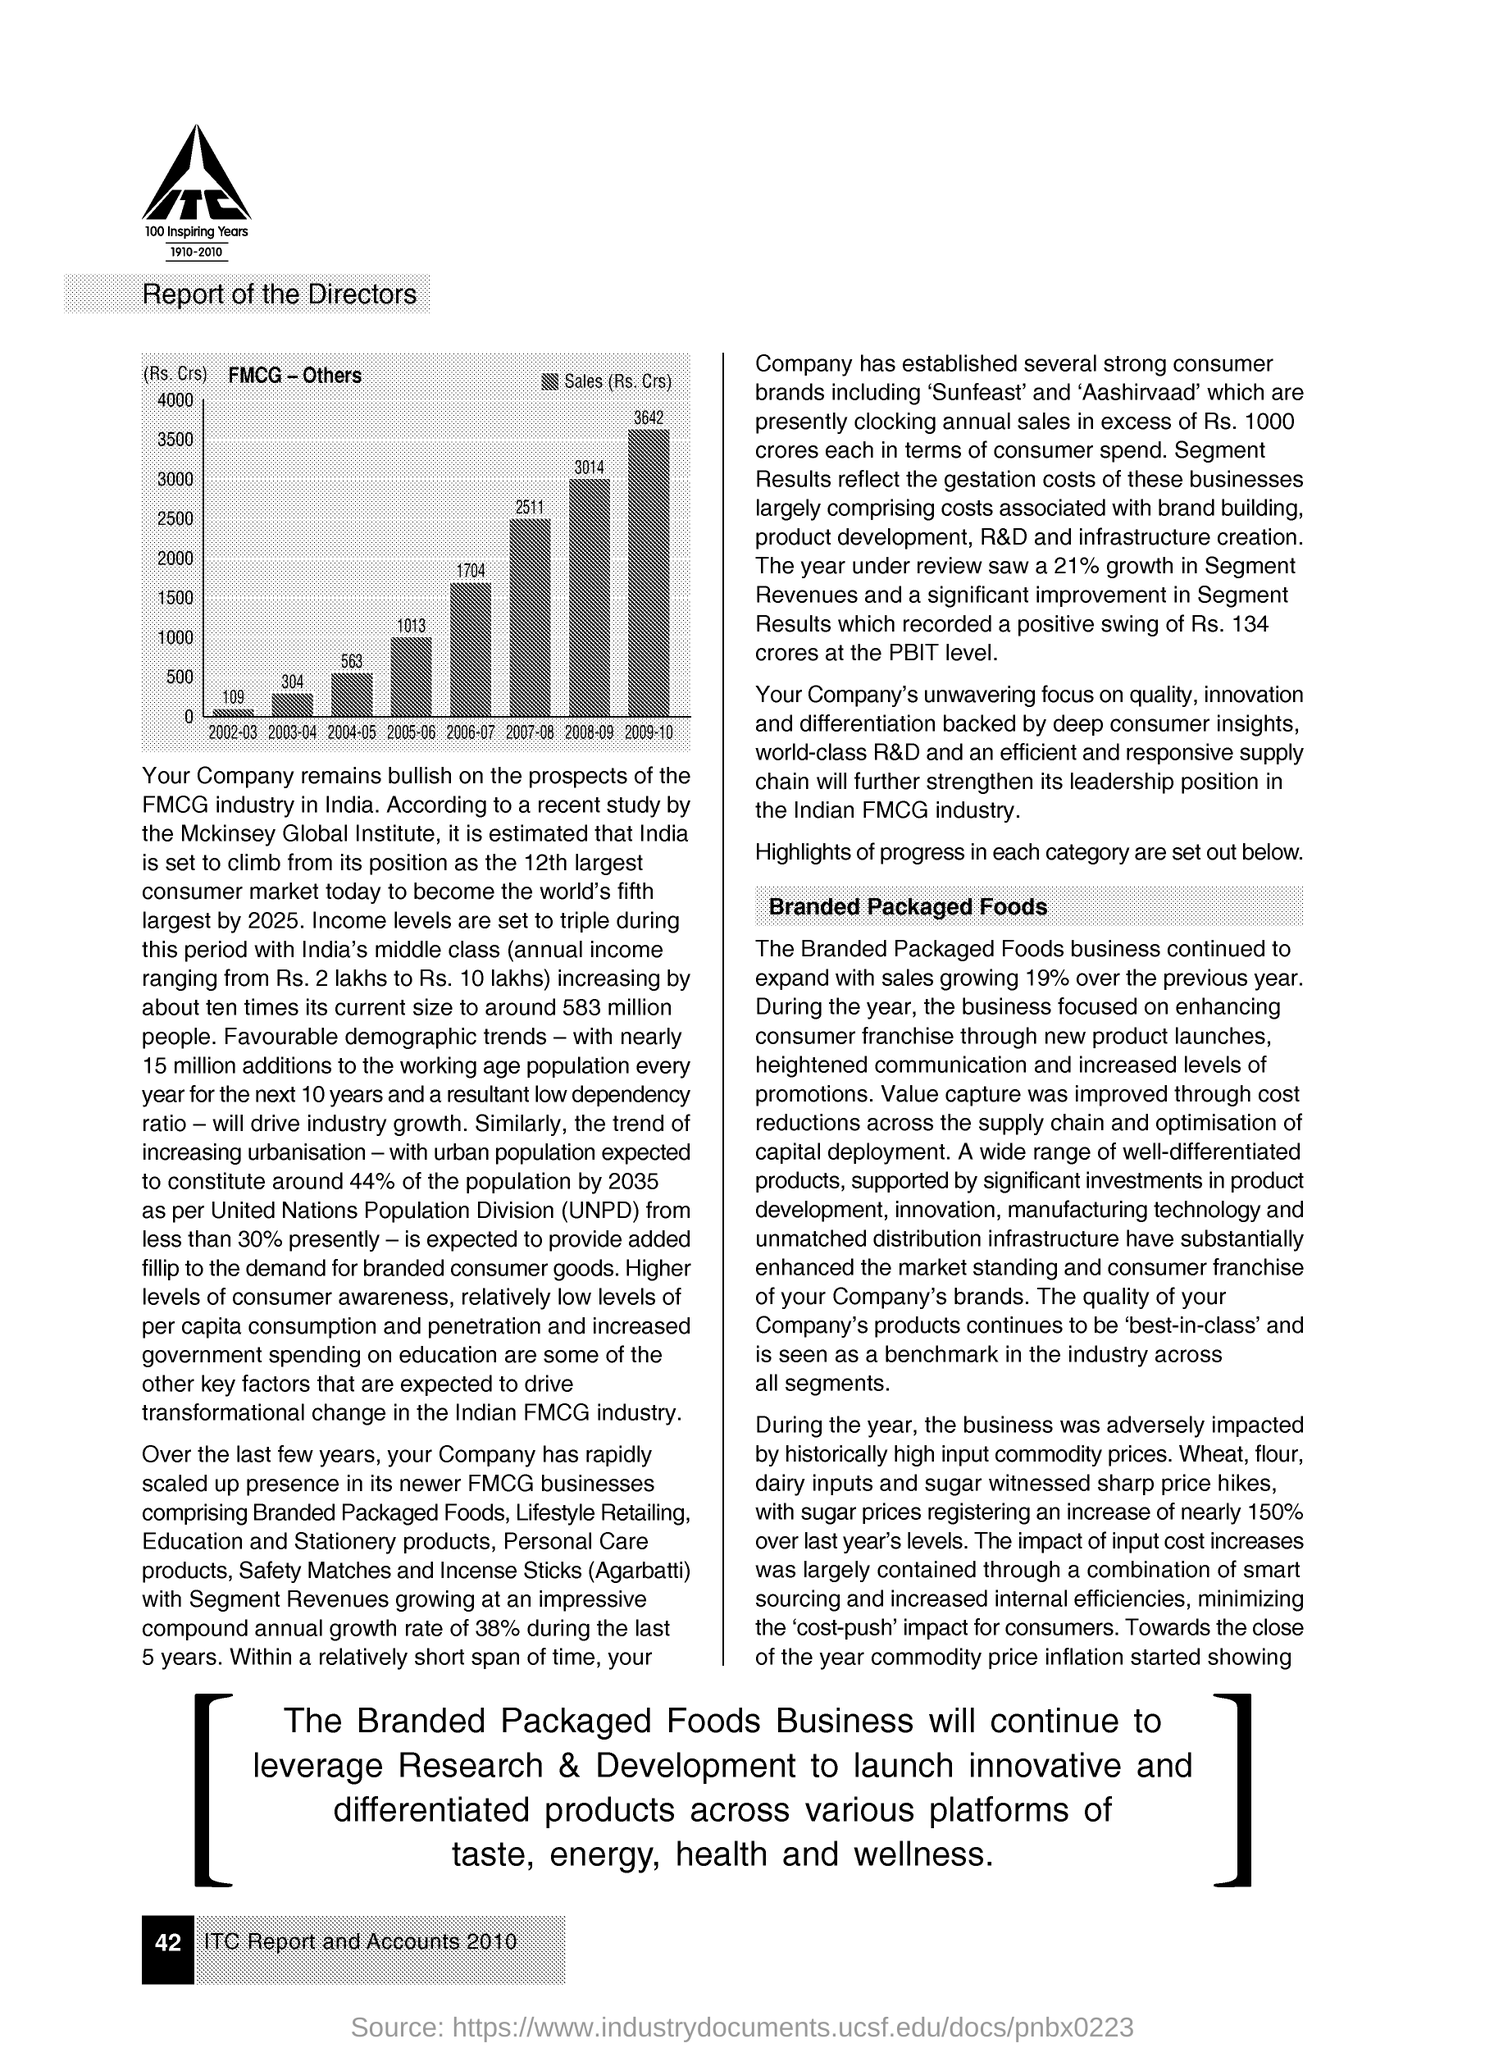What is written within the logo at the left top corner of the page?
Ensure brevity in your answer.  ITC. What is on the Y-axis of the graph?
Your answer should be very brief. (Rs. Crs). What is maximum value mentioned on y-axis?
Provide a succinct answer. 4000 (Rs. Crs). Mention the amount of Sales(Rs.Crs) for the year 2009-10?
Give a very brief answer. 3642(Rs. Crs). What is the page number given at the left bottom of the page?
Offer a very short reply. 42. Which year shows lowest sales as per graph?
Give a very brief answer. 2002-03. Which year has sales of 1704(Rs. Crs)?
Provide a succinct answer. 2006-07. Which "100 Inspiring Years" is mentioned under the logo?
Offer a terse response. 1910-2010. 